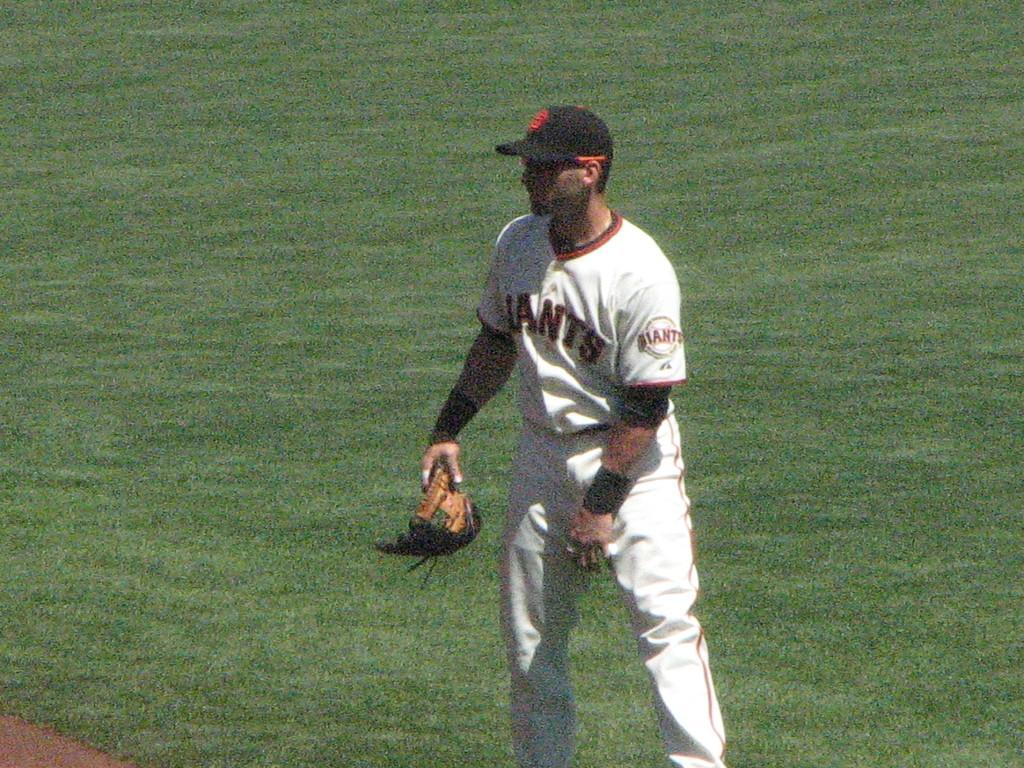Can you describe this image briefly? In this image I can see a man is standing in the ground, he wore white color dress and black color cap. 